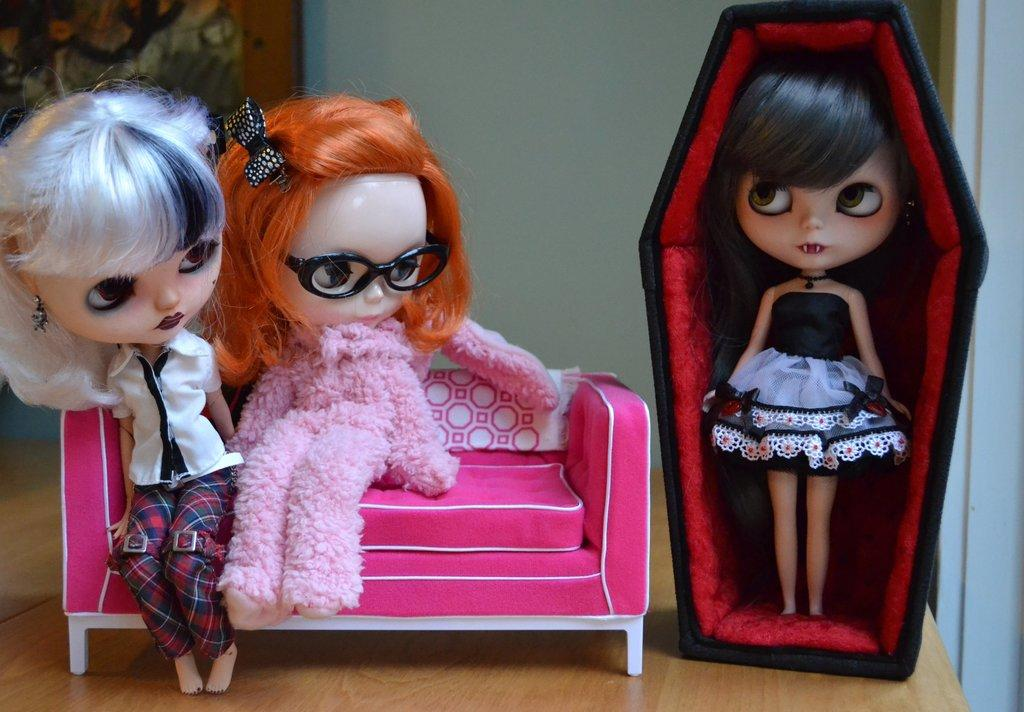How many toys are visible in the image? There are three toys in the image. What is the position of one of the toys? One toy is standing. Where are the other two toys located? Two toys are sitting on a couch. What type of material is the board made of? The wooden board in the image is made of wood. What can be seen in the background of the image? There is a wall in the background of the image. What type of collar is visible on the toys in the image? There are no collars present on the toys in the image. How many bikes are parked next to the couch in the image? There are no bikes present in the image. 